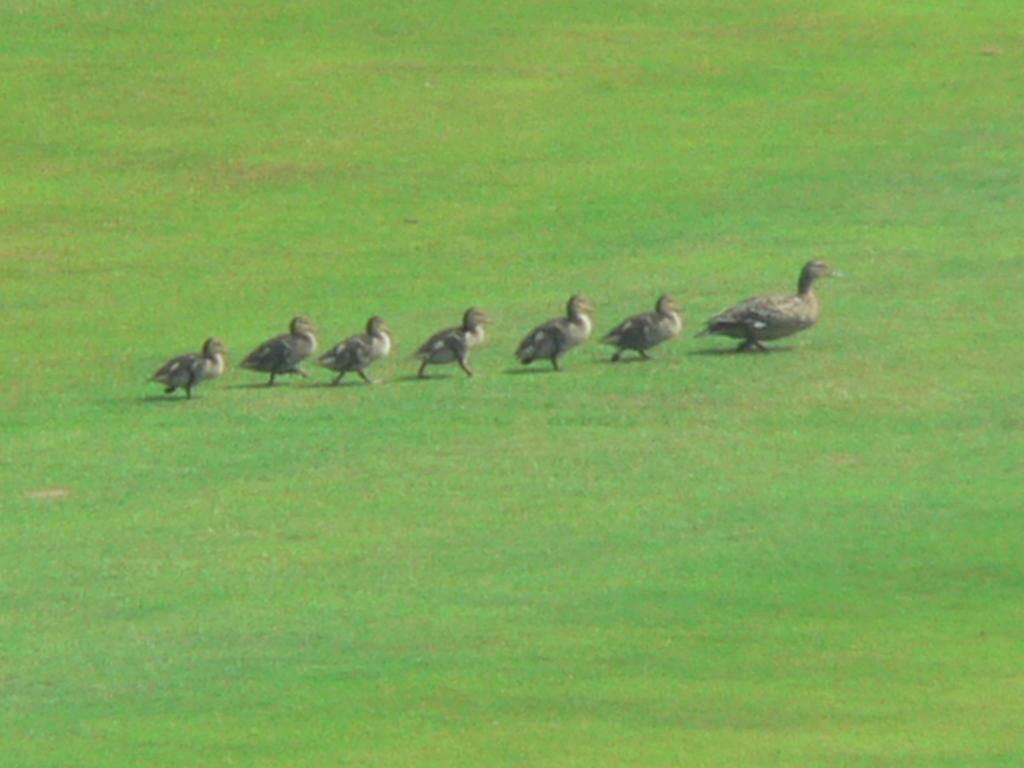What animal is present in the image? There is a duck in the image. Are there any offspring of the duck visible in the image? Yes, the duck has babies in the image. What type of terrain is visible in the image? The land is grassy in the image. What is the cause of death for the duck in the image? There is no indication of death or any related event in the image. --- Facts: 1. There is a car in the image. 2. The car is red. 3. The car has four wheels. 4. The car is parked on the street. 5. There are people walking on the sidewalk. Absurd Topics: airplane, ocean, fish Conversation: What type of vehicle is present in the image? There is a car in the image. What is the color of the car? The car is red. How many wheels does the car have? The car has four wheels. Where is the car located in the image? The car is parked on the street. What else can be seen in the image? There are people walking on the sidewalk. Reasoning: Let's think step by step in order to ${produce the conversation}. We start by identifying the main subject of the image, which is the car. Next, we describe specific features of the car, such as the color and the number of wheels. Then, we observe the car's location in the image, which is parked on the street. After that, we expand the conversation to include other elements present in the image, such as the people walking on the sidewalk. Absurd Question/Answer: Can you see any airplanes flying over the car in the image? No, there are no airplanes visible in the image. --- Facts: 1. There is a group of people in the image. 2. The people are wearing hats. 3. The people are holding hands. 4. The people are standing in a circle. 5. The background of the image includes trees. Absurd Topics: elephant, jungle, monkey Conversation: How many people are present in the image? There is a group of people in the image. What are the people wearing on their heads? The people are wearing hats. What are the people doing in the image? The people are holding hands. How are the people positioned in the image? The people are standing in a circle. What can be seen in the background of the image? The background of the image includes trees. Reasoning: Let's think step by step in order to ${produce the conversation}. We start by identifying the main subject of the image, which is the group of people. Next, we describe specific features of the people, such as the hats they are wearing. Then, we observe the actions of the people, noting that they are holding hands and standing in 